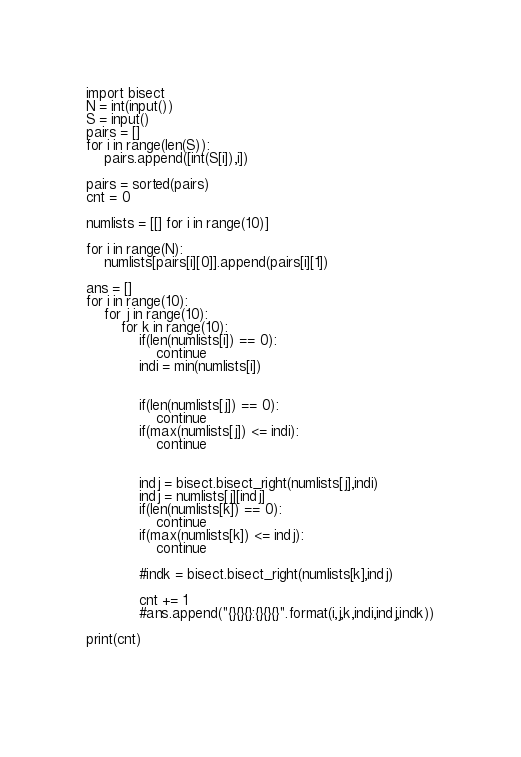Convert code to text. <code><loc_0><loc_0><loc_500><loc_500><_Python_>import bisect
N = int(input())
S = input()
pairs = []
for i in range(len(S)):
    pairs.append([int(S[i]),i])

pairs = sorted(pairs)
cnt = 0

numlists = [[] for i in range(10)]

for i in range(N):
    numlists[pairs[i][0]].append(pairs[i][1])

ans = []
for i in range(10):
    for j in range(10):
        for k in range(10):
            if(len(numlists[i]) == 0):
                continue
            indi = min(numlists[i])


            if(len(numlists[j]) == 0):
                continue
            if(max(numlists[j]) <= indi):
                continue
            
            
            indj = bisect.bisect_right(numlists[j],indi)
            indj = numlists[j][indj]
            if(len(numlists[k]) == 0):
                continue
            if(max(numlists[k]) <= indj):
                continue

            #indk = bisect.bisect_right(numlists[k],indj)

            cnt += 1
            #ans.append("{}{}{}:{}{}{}".format(i,j,k,indi,indj,indk))

print(cnt)

    </code> 